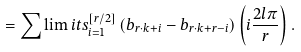<formula> <loc_0><loc_0><loc_500><loc_500>= \sum \lim i t s _ { i = 1 } ^ { \left [ r / 2 \right ] } \left ( b _ { r \cdot k + i } - b _ { r \cdot k + r - i } \right ) \left ( i \frac { 2 l \pi } { r } \right ) .</formula> 